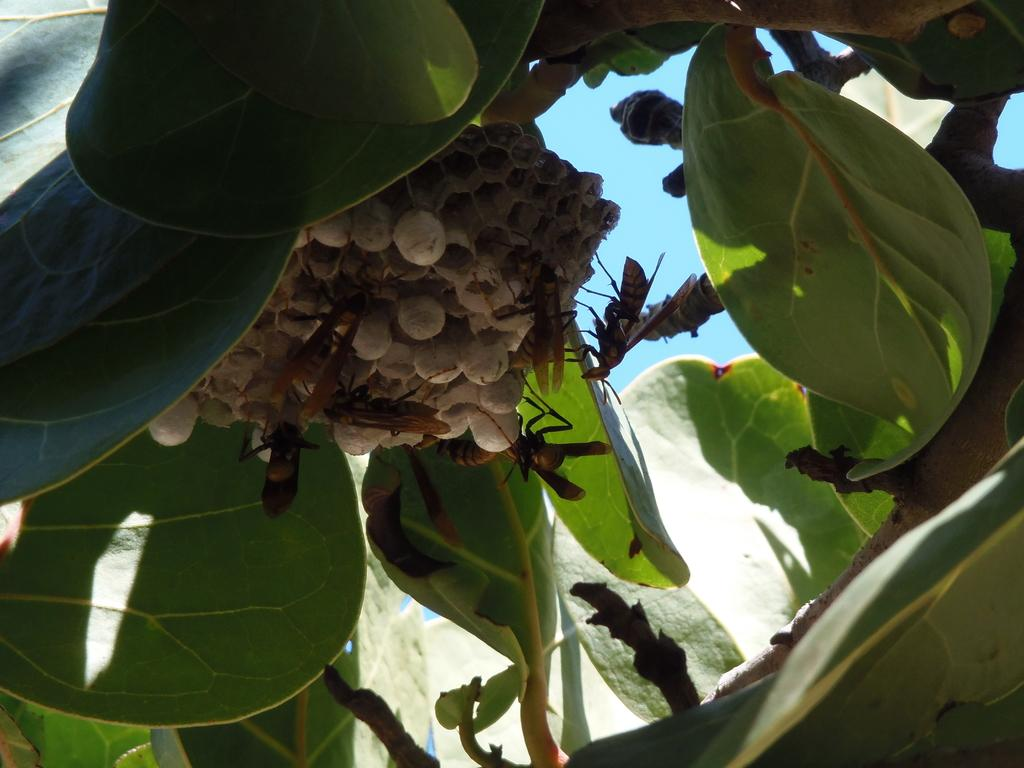What is one of the main subjects in the picture? There is a tree in the picture. What other creatures can be seen in the image? There are insects that look like cockroaches in the picture. What are the insects sitting on? The insects are on white color balls. What can be seen in the background of the picture? The sky is visible in the background of the picture. What is the color of the sky in the image? The sky is blue in color. What is the price of the building in the image? There is no building present in the image, so it is not possible to determine its price. 